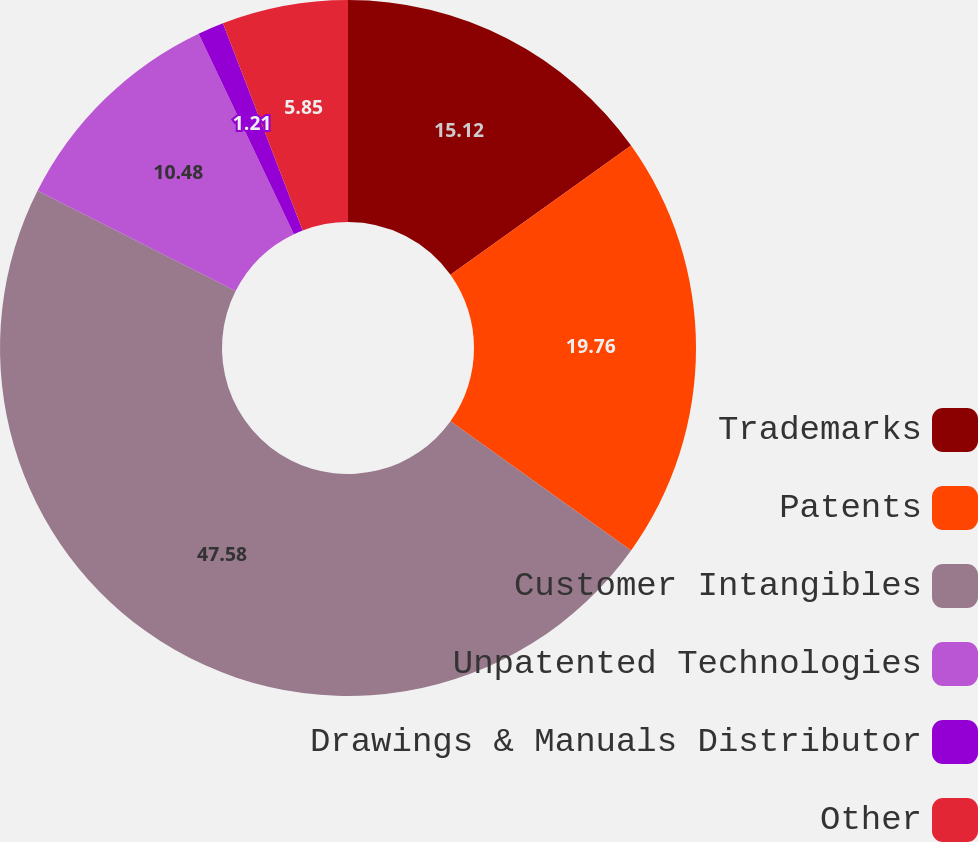<chart> <loc_0><loc_0><loc_500><loc_500><pie_chart><fcel>Trademarks<fcel>Patents<fcel>Customer Intangibles<fcel>Unpatented Technologies<fcel>Drawings & Manuals Distributor<fcel>Other<nl><fcel>15.12%<fcel>19.76%<fcel>47.58%<fcel>10.48%<fcel>1.21%<fcel>5.85%<nl></chart> 